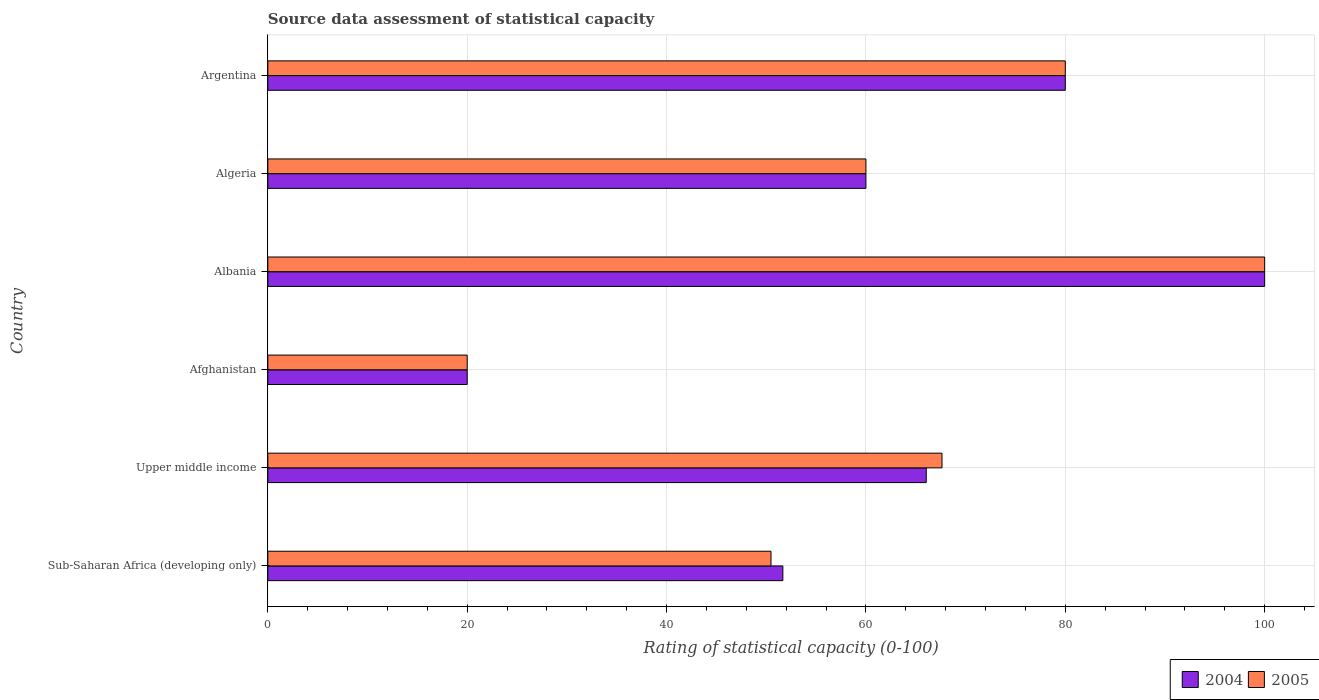How many groups of bars are there?
Provide a succinct answer. 6. Are the number of bars per tick equal to the number of legend labels?
Ensure brevity in your answer.  Yes. How many bars are there on the 4th tick from the top?
Provide a succinct answer. 2. How many bars are there on the 3rd tick from the bottom?
Provide a succinct answer. 2. What is the label of the 3rd group of bars from the top?
Your answer should be compact. Albania. Across all countries, what is the minimum rating of statistical capacity in 2004?
Make the answer very short. 20. In which country was the rating of statistical capacity in 2005 maximum?
Your answer should be very brief. Albania. In which country was the rating of statistical capacity in 2004 minimum?
Provide a succinct answer. Afghanistan. What is the total rating of statistical capacity in 2005 in the graph?
Offer a terse response. 378.11. What is the difference between the rating of statistical capacity in 2005 in Albania and that in Upper middle income?
Offer a terse response. 32.37. What is the difference between the rating of statistical capacity in 2005 in Afghanistan and the rating of statistical capacity in 2004 in Argentina?
Keep it short and to the point. -60. What is the average rating of statistical capacity in 2005 per country?
Keep it short and to the point. 63.02. In how many countries, is the rating of statistical capacity in 2005 greater than 36 ?
Ensure brevity in your answer.  5. What is the ratio of the rating of statistical capacity in 2004 in Albania to that in Upper middle income?
Ensure brevity in your answer.  1.51. Is the rating of statistical capacity in 2004 in Afghanistan less than that in Albania?
Give a very brief answer. Yes. Is the difference between the rating of statistical capacity in 2005 in Afghanistan and Albania greater than the difference between the rating of statistical capacity in 2004 in Afghanistan and Albania?
Keep it short and to the point. No. In how many countries, is the rating of statistical capacity in 2005 greater than the average rating of statistical capacity in 2005 taken over all countries?
Keep it short and to the point. 3. What does the 2nd bar from the bottom in Afghanistan represents?
Provide a succinct answer. 2005. How many bars are there?
Keep it short and to the point. 12. How many countries are there in the graph?
Your answer should be compact. 6. What is the difference between two consecutive major ticks on the X-axis?
Give a very brief answer. 20. Does the graph contain any zero values?
Provide a succinct answer. No. Does the graph contain grids?
Your answer should be compact. Yes. Where does the legend appear in the graph?
Provide a short and direct response. Bottom right. How are the legend labels stacked?
Your answer should be compact. Horizontal. What is the title of the graph?
Offer a terse response. Source data assessment of statistical capacity. Does "1984" appear as one of the legend labels in the graph?
Your answer should be very brief. No. What is the label or title of the X-axis?
Offer a very short reply. Rating of statistical capacity (0-100). What is the label or title of the Y-axis?
Your response must be concise. Country. What is the Rating of statistical capacity (0-100) of 2004 in Sub-Saharan Africa (developing only)?
Provide a short and direct response. 51.67. What is the Rating of statistical capacity (0-100) of 2005 in Sub-Saharan Africa (developing only)?
Your answer should be very brief. 50.48. What is the Rating of statistical capacity (0-100) of 2004 in Upper middle income?
Offer a very short reply. 66.05. What is the Rating of statistical capacity (0-100) in 2005 in Upper middle income?
Your response must be concise. 67.63. What is the Rating of statistical capacity (0-100) of 2005 in Afghanistan?
Provide a short and direct response. 20. What is the Rating of statistical capacity (0-100) in 2005 in Albania?
Your answer should be very brief. 100. What is the Rating of statistical capacity (0-100) of 2004 in Algeria?
Ensure brevity in your answer.  60. Across all countries, what is the maximum Rating of statistical capacity (0-100) in 2004?
Give a very brief answer. 100. Across all countries, what is the maximum Rating of statistical capacity (0-100) in 2005?
Your answer should be compact. 100. Across all countries, what is the minimum Rating of statistical capacity (0-100) in 2004?
Provide a short and direct response. 20. What is the total Rating of statistical capacity (0-100) of 2004 in the graph?
Provide a short and direct response. 377.72. What is the total Rating of statistical capacity (0-100) of 2005 in the graph?
Give a very brief answer. 378.11. What is the difference between the Rating of statistical capacity (0-100) in 2004 in Sub-Saharan Africa (developing only) and that in Upper middle income?
Offer a terse response. -14.39. What is the difference between the Rating of statistical capacity (0-100) in 2005 in Sub-Saharan Africa (developing only) and that in Upper middle income?
Ensure brevity in your answer.  -17.16. What is the difference between the Rating of statistical capacity (0-100) in 2004 in Sub-Saharan Africa (developing only) and that in Afghanistan?
Keep it short and to the point. 31.67. What is the difference between the Rating of statistical capacity (0-100) in 2005 in Sub-Saharan Africa (developing only) and that in Afghanistan?
Your response must be concise. 30.48. What is the difference between the Rating of statistical capacity (0-100) of 2004 in Sub-Saharan Africa (developing only) and that in Albania?
Your answer should be very brief. -48.33. What is the difference between the Rating of statistical capacity (0-100) of 2005 in Sub-Saharan Africa (developing only) and that in Albania?
Your answer should be compact. -49.52. What is the difference between the Rating of statistical capacity (0-100) of 2004 in Sub-Saharan Africa (developing only) and that in Algeria?
Provide a succinct answer. -8.33. What is the difference between the Rating of statistical capacity (0-100) of 2005 in Sub-Saharan Africa (developing only) and that in Algeria?
Your response must be concise. -9.52. What is the difference between the Rating of statistical capacity (0-100) of 2004 in Sub-Saharan Africa (developing only) and that in Argentina?
Provide a succinct answer. -28.33. What is the difference between the Rating of statistical capacity (0-100) of 2005 in Sub-Saharan Africa (developing only) and that in Argentina?
Your response must be concise. -29.52. What is the difference between the Rating of statistical capacity (0-100) of 2004 in Upper middle income and that in Afghanistan?
Offer a very short reply. 46.05. What is the difference between the Rating of statistical capacity (0-100) of 2005 in Upper middle income and that in Afghanistan?
Your answer should be very brief. 47.63. What is the difference between the Rating of statistical capacity (0-100) in 2004 in Upper middle income and that in Albania?
Make the answer very short. -33.95. What is the difference between the Rating of statistical capacity (0-100) of 2005 in Upper middle income and that in Albania?
Keep it short and to the point. -32.37. What is the difference between the Rating of statistical capacity (0-100) of 2004 in Upper middle income and that in Algeria?
Your answer should be compact. 6.05. What is the difference between the Rating of statistical capacity (0-100) of 2005 in Upper middle income and that in Algeria?
Offer a terse response. 7.63. What is the difference between the Rating of statistical capacity (0-100) in 2004 in Upper middle income and that in Argentina?
Your answer should be compact. -13.95. What is the difference between the Rating of statistical capacity (0-100) of 2005 in Upper middle income and that in Argentina?
Offer a terse response. -12.37. What is the difference between the Rating of statistical capacity (0-100) in 2004 in Afghanistan and that in Albania?
Your answer should be very brief. -80. What is the difference between the Rating of statistical capacity (0-100) of 2005 in Afghanistan and that in Albania?
Your answer should be compact. -80. What is the difference between the Rating of statistical capacity (0-100) in 2004 in Afghanistan and that in Algeria?
Your answer should be very brief. -40. What is the difference between the Rating of statistical capacity (0-100) of 2004 in Afghanistan and that in Argentina?
Ensure brevity in your answer.  -60. What is the difference between the Rating of statistical capacity (0-100) in 2005 in Afghanistan and that in Argentina?
Your answer should be compact. -60. What is the difference between the Rating of statistical capacity (0-100) of 2005 in Albania and that in Algeria?
Give a very brief answer. 40. What is the difference between the Rating of statistical capacity (0-100) in 2004 in Algeria and that in Argentina?
Offer a terse response. -20. What is the difference between the Rating of statistical capacity (0-100) in 2005 in Algeria and that in Argentina?
Give a very brief answer. -20. What is the difference between the Rating of statistical capacity (0-100) in 2004 in Sub-Saharan Africa (developing only) and the Rating of statistical capacity (0-100) in 2005 in Upper middle income?
Your response must be concise. -15.96. What is the difference between the Rating of statistical capacity (0-100) in 2004 in Sub-Saharan Africa (developing only) and the Rating of statistical capacity (0-100) in 2005 in Afghanistan?
Your answer should be compact. 31.67. What is the difference between the Rating of statistical capacity (0-100) of 2004 in Sub-Saharan Africa (developing only) and the Rating of statistical capacity (0-100) of 2005 in Albania?
Provide a succinct answer. -48.33. What is the difference between the Rating of statistical capacity (0-100) in 2004 in Sub-Saharan Africa (developing only) and the Rating of statistical capacity (0-100) in 2005 in Algeria?
Your answer should be very brief. -8.33. What is the difference between the Rating of statistical capacity (0-100) of 2004 in Sub-Saharan Africa (developing only) and the Rating of statistical capacity (0-100) of 2005 in Argentina?
Offer a terse response. -28.33. What is the difference between the Rating of statistical capacity (0-100) of 2004 in Upper middle income and the Rating of statistical capacity (0-100) of 2005 in Afghanistan?
Offer a very short reply. 46.05. What is the difference between the Rating of statistical capacity (0-100) in 2004 in Upper middle income and the Rating of statistical capacity (0-100) in 2005 in Albania?
Ensure brevity in your answer.  -33.95. What is the difference between the Rating of statistical capacity (0-100) of 2004 in Upper middle income and the Rating of statistical capacity (0-100) of 2005 in Algeria?
Your answer should be very brief. 6.05. What is the difference between the Rating of statistical capacity (0-100) of 2004 in Upper middle income and the Rating of statistical capacity (0-100) of 2005 in Argentina?
Your answer should be compact. -13.95. What is the difference between the Rating of statistical capacity (0-100) of 2004 in Afghanistan and the Rating of statistical capacity (0-100) of 2005 in Albania?
Offer a terse response. -80. What is the difference between the Rating of statistical capacity (0-100) of 2004 in Afghanistan and the Rating of statistical capacity (0-100) of 2005 in Argentina?
Ensure brevity in your answer.  -60. What is the difference between the Rating of statistical capacity (0-100) of 2004 in Albania and the Rating of statistical capacity (0-100) of 2005 in Argentina?
Give a very brief answer. 20. What is the difference between the Rating of statistical capacity (0-100) of 2004 in Algeria and the Rating of statistical capacity (0-100) of 2005 in Argentina?
Ensure brevity in your answer.  -20. What is the average Rating of statistical capacity (0-100) in 2004 per country?
Offer a very short reply. 62.95. What is the average Rating of statistical capacity (0-100) of 2005 per country?
Offer a very short reply. 63.02. What is the difference between the Rating of statistical capacity (0-100) in 2004 and Rating of statistical capacity (0-100) in 2005 in Sub-Saharan Africa (developing only)?
Provide a short and direct response. 1.19. What is the difference between the Rating of statistical capacity (0-100) of 2004 and Rating of statistical capacity (0-100) of 2005 in Upper middle income?
Offer a very short reply. -1.58. What is the difference between the Rating of statistical capacity (0-100) in 2004 and Rating of statistical capacity (0-100) in 2005 in Afghanistan?
Your response must be concise. 0. What is the difference between the Rating of statistical capacity (0-100) in 2004 and Rating of statistical capacity (0-100) in 2005 in Argentina?
Your answer should be very brief. 0. What is the ratio of the Rating of statistical capacity (0-100) of 2004 in Sub-Saharan Africa (developing only) to that in Upper middle income?
Give a very brief answer. 0.78. What is the ratio of the Rating of statistical capacity (0-100) of 2005 in Sub-Saharan Africa (developing only) to that in Upper middle income?
Give a very brief answer. 0.75. What is the ratio of the Rating of statistical capacity (0-100) in 2004 in Sub-Saharan Africa (developing only) to that in Afghanistan?
Make the answer very short. 2.58. What is the ratio of the Rating of statistical capacity (0-100) of 2005 in Sub-Saharan Africa (developing only) to that in Afghanistan?
Provide a short and direct response. 2.52. What is the ratio of the Rating of statistical capacity (0-100) of 2004 in Sub-Saharan Africa (developing only) to that in Albania?
Your answer should be very brief. 0.52. What is the ratio of the Rating of statistical capacity (0-100) of 2005 in Sub-Saharan Africa (developing only) to that in Albania?
Ensure brevity in your answer.  0.5. What is the ratio of the Rating of statistical capacity (0-100) of 2004 in Sub-Saharan Africa (developing only) to that in Algeria?
Your answer should be compact. 0.86. What is the ratio of the Rating of statistical capacity (0-100) in 2005 in Sub-Saharan Africa (developing only) to that in Algeria?
Provide a succinct answer. 0.84. What is the ratio of the Rating of statistical capacity (0-100) in 2004 in Sub-Saharan Africa (developing only) to that in Argentina?
Your answer should be compact. 0.65. What is the ratio of the Rating of statistical capacity (0-100) in 2005 in Sub-Saharan Africa (developing only) to that in Argentina?
Ensure brevity in your answer.  0.63. What is the ratio of the Rating of statistical capacity (0-100) in 2004 in Upper middle income to that in Afghanistan?
Provide a short and direct response. 3.3. What is the ratio of the Rating of statistical capacity (0-100) in 2005 in Upper middle income to that in Afghanistan?
Give a very brief answer. 3.38. What is the ratio of the Rating of statistical capacity (0-100) of 2004 in Upper middle income to that in Albania?
Provide a short and direct response. 0.66. What is the ratio of the Rating of statistical capacity (0-100) of 2005 in Upper middle income to that in Albania?
Make the answer very short. 0.68. What is the ratio of the Rating of statistical capacity (0-100) of 2004 in Upper middle income to that in Algeria?
Ensure brevity in your answer.  1.1. What is the ratio of the Rating of statistical capacity (0-100) of 2005 in Upper middle income to that in Algeria?
Your response must be concise. 1.13. What is the ratio of the Rating of statistical capacity (0-100) in 2004 in Upper middle income to that in Argentina?
Give a very brief answer. 0.83. What is the ratio of the Rating of statistical capacity (0-100) in 2005 in Upper middle income to that in Argentina?
Your answer should be very brief. 0.85. What is the ratio of the Rating of statistical capacity (0-100) in 2004 in Afghanistan to that in Algeria?
Provide a succinct answer. 0.33. What is the ratio of the Rating of statistical capacity (0-100) of 2004 in Afghanistan to that in Argentina?
Offer a terse response. 0.25. What is the ratio of the Rating of statistical capacity (0-100) of 2004 in Albania to that in Algeria?
Offer a terse response. 1.67. What is the ratio of the Rating of statistical capacity (0-100) in 2005 in Albania to that in Algeria?
Offer a terse response. 1.67. What is the difference between the highest and the second highest Rating of statistical capacity (0-100) of 2005?
Offer a very short reply. 20. What is the difference between the highest and the lowest Rating of statistical capacity (0-100) in 2004?
Keep it short and to the point. 80. What is the difference between the highest and the lowest Rating of statistical capacity (0-100) in 2005?
Provide a short and direct response. 80. 